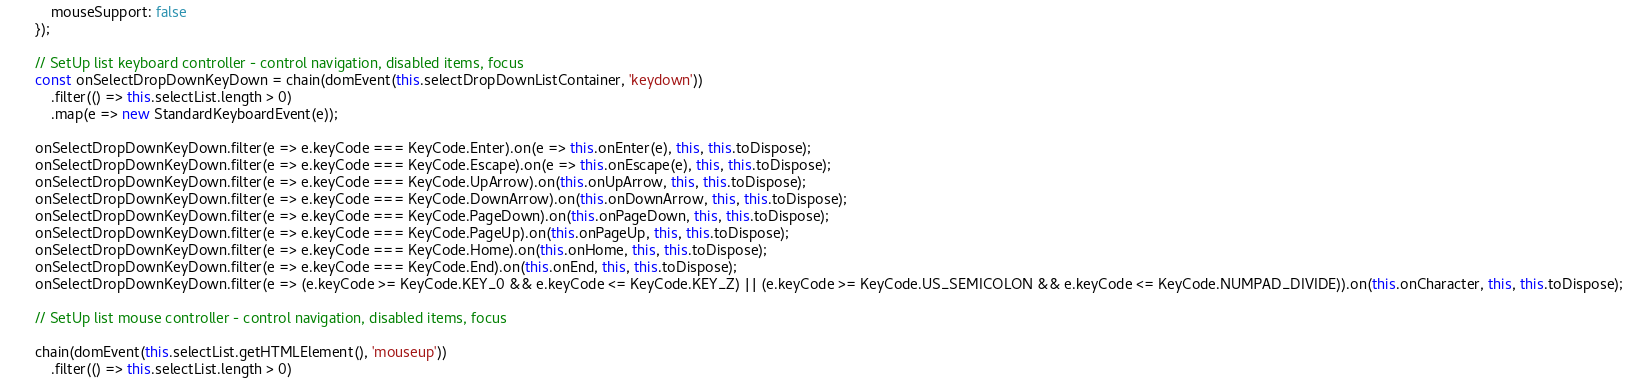Convert code to text. <code><loc_0><loc_0><loc_500><loc_500><_TypeScript_>			mouseSupport: false
		});

		// SetUp list keyboard controller - control navigation, disabled items, focus
		const onSelectDropDownKeyDown = chain(domEvent(this.selectDropDownListContainer, 'keydown'))
			.filter(() => this.selectList.length > 0)
			.map(e => new StandardKeyboardEvent(e));

		onSelectDropDownKeyDown.filter(e => e.keyCode === KeyCode.Enter).on(e => this.onEnter(e), this, this.toDispose);
		onSelectDropDownKeyDown.filter(e => e.keyCode === KeyCode.Escape).on(e => this.onEscape(e), this, this.toDispose);
		onSelectDropDownKeyDown.filter(e => e.keyCode === KeyCode.UpArrow).on(this.onUpArrow, this, this.toDispose);
		onSelectDropDownKeyDown.filter(e => e.keyCode === KeyCode.DownArrow).on(this.onDownArrow, this, this.toDispose);
		onSelectDropDownKeyDown.filter(e => e.keyCode === KeyCode.PageDown).on(this.onPageDown, this, this.toDispose);
		onSelectDropDownKeyDown.filter(e => e.keyCode === KeyCode.PageUp).on(this.onPageUp, this, this.toDispose);
		onSelectDropDownKeyDown.filter(e => e.keyCode === KeyCode.Home).on(this.onHome, this, this.toDispose);
		onSelectDropDownKeyDown.filter(e => e.keyCode === KeyCode.End).on(this.onEnd, this, this.toDispose);
		onSelectDropDownKeyDown.filter(e => (e.keyCode >= KeyCode.KEY_0 && e.keyCode <= KeyCode.KEY_Z) || (e.keyCode >= KeyCode.US_SEMICOLON && e.keyCode <= KeyCode.NUMPAD_DIVIDE)).on(this.onCharacter, this, this.toDispose);

		// SetUp list mouse controller - control navigation, disabled items, focus

		chain(domEvent(this.selectList.getHTMLElement(), 'mouseup'))
			.filter(() => this.selectList.length > 0)</code> 